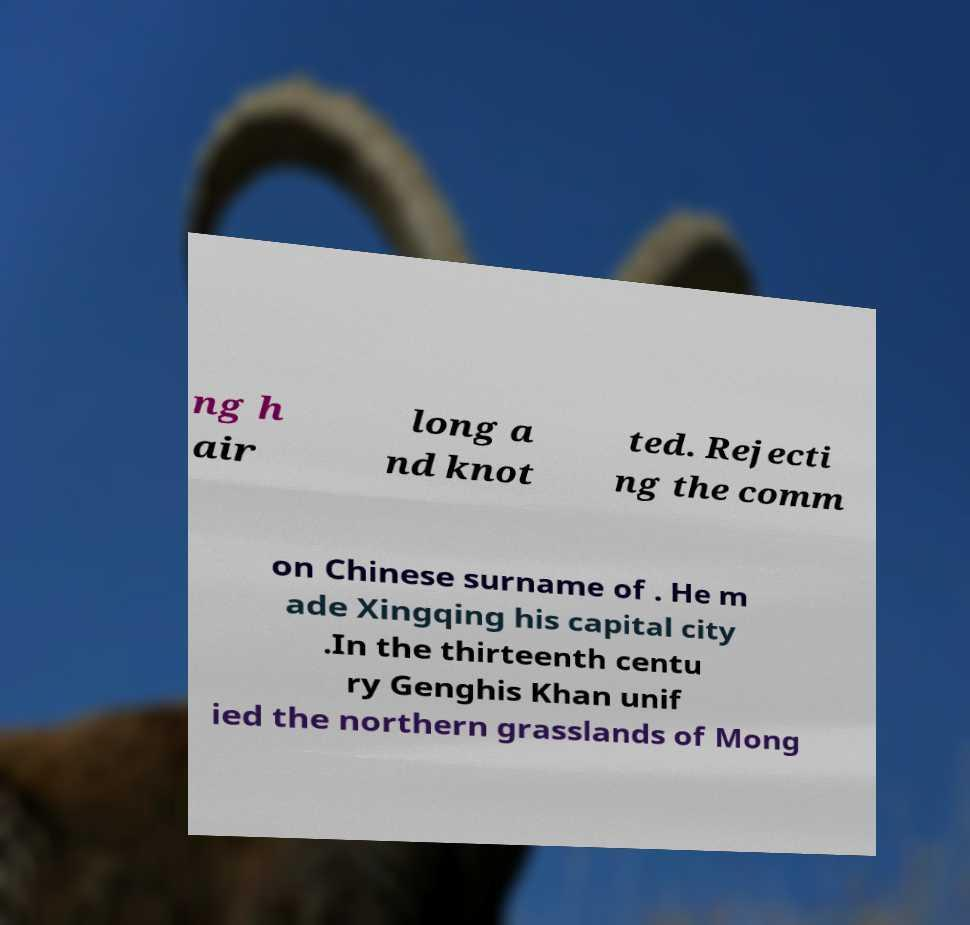Can you accurately transcribe the text from the provided image for me? ng h air long a nd knot ted. Rejecti ng the comm on Chinese surname of . He m ade Xingqing his capital city .In the thirteenth centu ry Genghis Khan unif ied the northern grasslands of Mong 